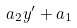Convert formula to latex. <formula><loc_0><loc_0><loc_500><loc_500>a _ { 2 } y ^ { \prime } + a _ { 1 }</formula> 